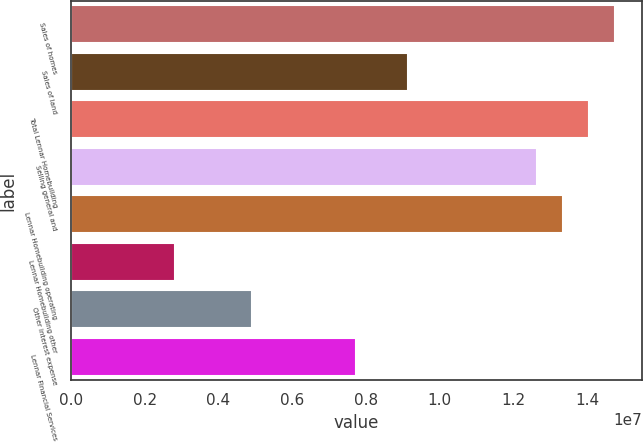<chart> <loc_0><loc_0><loc_500><loc_500><bar_chart><fcel>Sales of homes<fcel>Sales of land<fcel>Total Lennar Homebuilding<fcel>Selling general and<fcel>Lennar Homebuilding operating<fcel>Lennar Homebuilding other<fcel>Other interest expense<fcel>Lennar Financial Services<nl><fcel>1.47528e+07<fcel>9.13267e+06<fcel>1.40502e+07<fcel>1.26452e+07<fcel>1.33477e+07<fcel>2.81006e+06<fcel>4.91759e+06<fcel>7.72764e+06<nl></chart> 